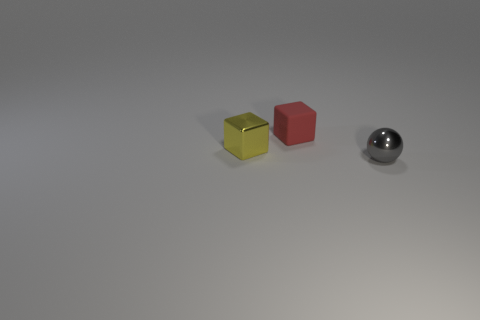Subtract 0 green balls. How many objects are left? 3 Subtract all blocks. How many objects are left? 1 Subtract 1 cubes. How many cubes are left? 1 Subtract all blue cubes. Subtract all cyan balls. How many cubes are left? 2 Subtract all blue cylinders. How many yellow blocks are left? 1 Subtract all purple metallic cylinders. Subtract all yellow metallic things. How many objects are left? 2 Add 2 shiny cubes. How many shiny cubes are left? 3 Add 2 tiny rubber objects. How many tiny rubber objects exist? 3 Add 1 metal things. How many objects exist? 4 